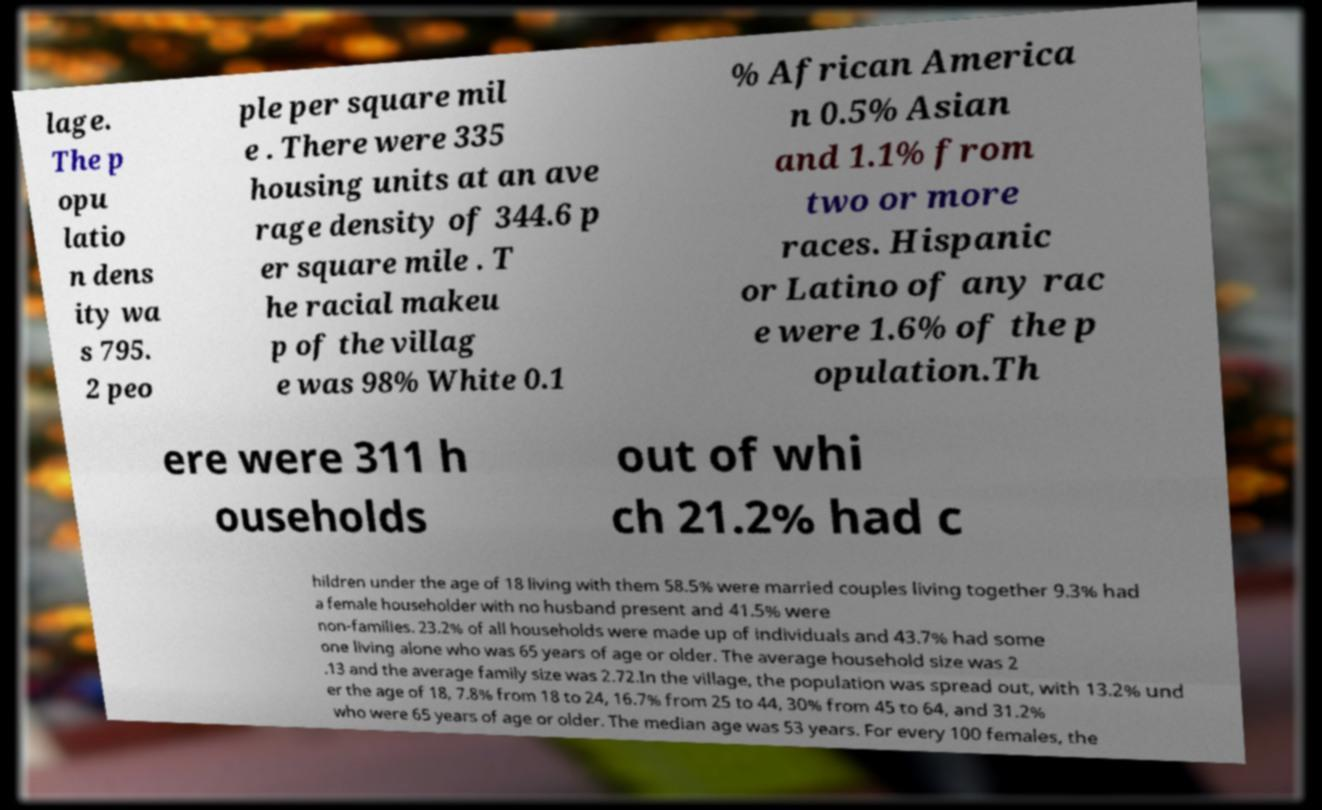Please read and relay the text visible in this image. What does it say? lage. The p opu latio n dens ity wa s 795. 2 peo ple per square mil e . There were 335 housing units at an ave rage density of 344.6 p er square mile . T he racial makeu p of the villag e was 98% White 0.1 % African America n 0.5% Asian and 1.1% from two or more races. Hispanic or Latino of any rac e were 1.6% of the p opulation.Th ere were 311 h ouseholds out of whi ch 21.2% had c hildren under the age of 18 living with them 58.5% were married couples living together 9.3% had a female householder with no husband present and 41.5% were non-families. 23.2% of all households were made up of individuals and 43.7% had some one living alone who was 65 years of age or older. The average household size was 2 .13 and the average family size was 2.72.In the village, the population was spread out, with 13.2% und er the age of 18, 7.8% from 18 to 24, 16.7% from 25 to 44, 30% from 45 to 64, and 31.2% who were 65 years of age or older. The median age was 53 years. For every 100 females, the 